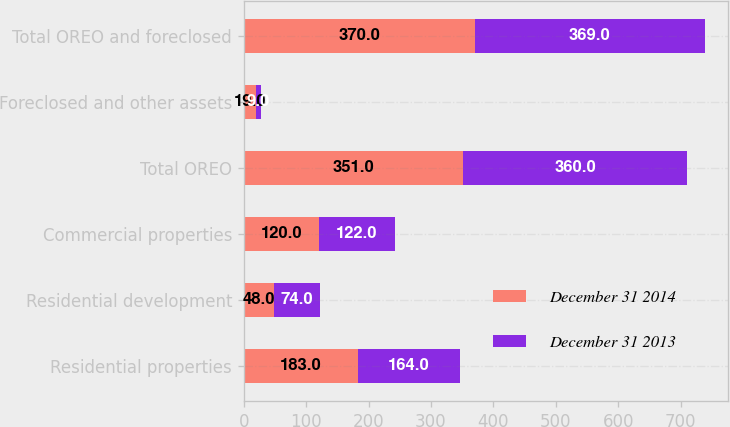Convert chart to OTSL. <chart><loc_0><loc_0><loc_500><loc_500><stacked_bar_chart><ecel><fcel>Residential properties<fcel>Residential development<fcel>Commercial properties<fcel>Total OREO<fcel>Foreclosed and other assets<fcel>Total OREO and foreclosed<nl><fcel>December 31 2014<fcel>183<fcel>48<fcel>120<fcel>351<fcel>19<fcel>370<nl><fcel>December 31 2013<fcel>164<fcel>74<fcel>122<fcel>360<fcel>9<fcel>369<nl></chart> 